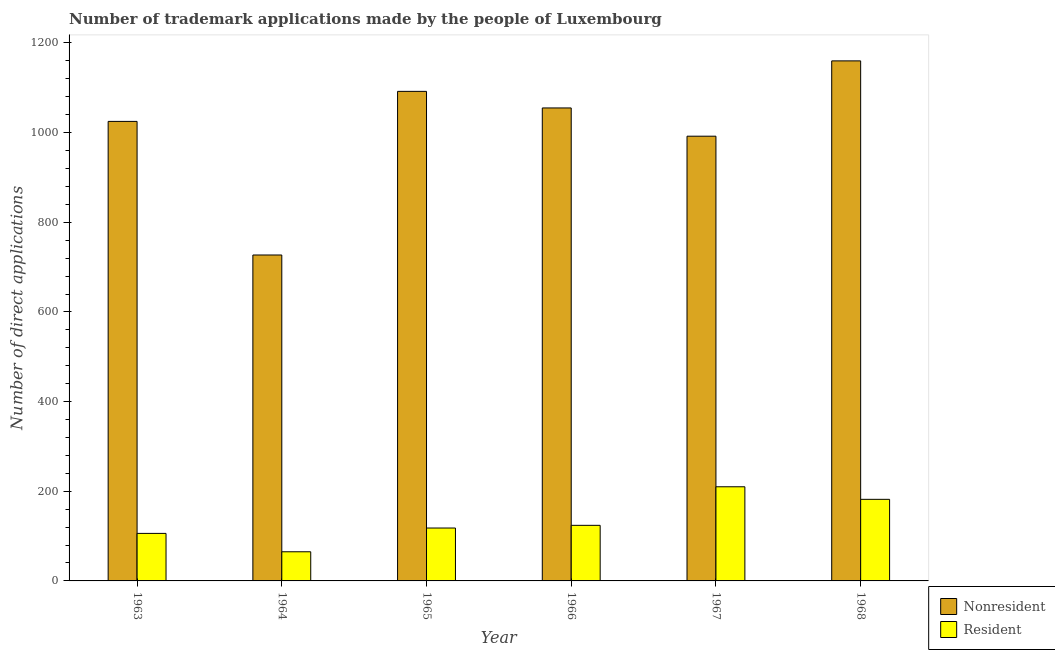How many different coloured bars are there?
Provide a short and direct response. 2. How many groups of bars are there?
Your answer should be compact. 6. What is the label of the 6th group of bars from the left?
Offer a very short reply. 1968. What is the number of trademark applications made by residents in 1965?
Give a very brief answer. 118. Across all years, what is the maximum number of trademark applications made by non residents?
Your answer should be compact. 1160. Across all years, what is the minimum number of trademark applications made by residents?
Your answer should be compact. 65. In which year was the number of trademark applications made by residents maximum?
Ensure brevity in your answer.  1967. In which year was the number of trademark applications made by non residents minimum?
Your answer should be compact. 1964. What is the total number of trademark applications made by non residents in the graph?
Your answer should be very brief. 6051. What is the difference between the number of trademark applications made by non residents in 1966 and that in 1967?
Keep it short and to the point. 63. What is the difference between the number of trademark applications made by non residents in 1967 and the number of trademark applications made by residents in 1966?
Offer a very short reply. -63. What is the average number of trademark applications made by residents per year?
Your answer should be compact. 134.17. In the year 1965, what is the difference between the number of trademark applications made by residents and number of trademark applications made by non residents?
Provide a succinct answer. 0. In how many years, is the number of trademark applications made by non residents greater than 200?
Your response must be concise. 6. What is the ratio of the number of trademark applications made by residents in 1965 to that in 1966?
Provide a short and direct response. 0.95. Is the number of trademark applications made by non residents in 1966 less than that in 1967?
Provide a short and direct response. No. Is the difference between the number of trademark applications made by residents in 1964 and 1965 greater than the difference between the number of trademark applications made by non residents in 1964 and 1965?
Your response must be concise. No. What is the difference between the highest and the lowest number of trademark applications made by residents?
Provide a succinct answer. 145. Is the sum of the number of trademark applications made by non residents in 1963 and 1966 greater than the maximum number of trademark applications made by residents across all years?
Offer a terse response. Yes. What does the 2nd bar from the left in 1963 represents?
Provide a short and direct response. Resident. What does the 1st bar from the right in 1967 represents?
Provide a short and direct response. Resident. Are all the bars in the graph horizontal?
Provide a succinct answer. No. How many years are there in the graph?
Your response must be concise. 6. Are the values on the major ticks of Y-axis written in scientific E-notation?
Provide a succinct answer. No. Does the graph contain any zero values?
Make the answer very short. No. Does the graph contain grids?
Your response must be concise. No. How many legend labels are there?
Your answer should be very brief. 2. What is the title of the graph?
Provide a succinct answer. Number of trademark applications made by the people of Luxembourg. Does "Nonresident" appear as one of the legend labels in the graph?
Offer a very short reply. Yes. What is the label or title of the Y-axis?
Provide a short and direct response. Number of direct applications. What is the Number of direct applications of Nonresident in 1963?
Offer a very short reply. 1025. What is the Number of direct applications in Resident in 1963?
Ensure brevity in your answer.  106. What is the Number of direct applications of Nonresident in 1964?
Keep it short and to the point. 727. What is the Number of direct applications in Resident in 1964?
Provide a short and direct response. 65. What is the Number of direct applications of Nonresident in 1965?
Provide a succinct answer. 1092. What is the Number of direct applications of Resident in 1965?
Provide a succinct answer. 118. What is the Number of direct applications of Nonresident in 1966?
Provide a short and direct response. 1055. What is the Number of direct applications of Resident in 1966?
Provide a succinct answer. 124. What is the Number of direct applications of Nonresident in 1967?
Keep it short and to the point. 992. What is the Number of direct applications of Resident in 1967?
Provide a succinct answer. 210. What is the Number of direct applications of Nonresident in 1968?
Make the answer very short. 1160. What is the Number of direct applications of Resident in 1968?
Your answer should be very brief. 182. Across all years, what is the maximum Number of direct applications of Nonresident?
Make the answer very short. 1160. Across all years, what is the maximum Number of direct applications of Resident?
Make the answer very short. 210. Across all years, what is the minimum Number of direct applications of Nonresident?
Your answer should be very brief. 727. Across all years, what is the minimum Number of direct applications of Resident?
Offer a terse response. 65. What is the total Number of direct applications of Nonresident in the graph?
Your answer should be compact. 6051. What is the total Number of direct applications of Resident in the graph?
Your answer should be very brief. 805. What is the difference between the Number of direct applications in Nonresident in 1963 and that in 1964?
Your answer should be compact. 298. What is the difference between the Number of direct applications of Nonresident in 1963 and that in 1965?
Your answer should be very brief. -67. What is the difference between the Number of direct applications of Resident in 1963 and that in 1965?
Offer a very short reply. -12. What is the difference between the Number of direct applications of Resident in 1963 and that in 1966?
Offer a very short reply. -18. What is the difference between the Number of direct applications in Resident in 1963 and that in 1967?
Provide a succinct answer. -104. What is the difference between the Number of direct applications of Nonresident in 1963 and that in 1968?
Offer a terse response. -135. What is the difference between the Number of direct applications of Resident in 1963 and that in 1968?
Ensure brevity in your answer.  -76. What is the difference between the Number of direct applications in Nonresident in 1964 and that in 1965?
Make the answer very short. -365. What is the difference between the Number of direct applications of Resident in 1964 and that in 1965?
Provide a short and direct response. -53. What is the difference between the Number of direct applications in Nonresident in 1964 and that in 1966?
Your answer should be compact. -328. What is the difference between the Number of direct applications in Resident in 1964 and that in 1966?
Provide a succinct answer. -59. What is the difference between the Number of direct applications of Nonresident in 1964 and that in 1967?
Ensure brevity in your answer.  -265. What is the difference between the Number of direct applications of Resident in 1964 and that in 1967?
Offer a terse response. -145. What is the difference between the Number of direct applications in Nonresident in 1964 and that in 1968?
Make the answer very short. -433. What is the difference between the Number of direct applications in Resident in 1964 and that in 1968?
Give a very brief answer. -117. What is the difference between the Number of direct applications in Resident in 1965 and that in 1967?
Ensure brevity in your answer.  -92. What is the difference between the Number of direct applications of Nonresident in 1965 and that in 1968?
Offer a very short reply. -68. What is the difference between the Number of direct applications in Resident in 1965 and that in 1968?
Your response must be concise. -64. What is the difference between the Number of direct applications of Nonresident in 1966 and that in 1967?
Provide a succinct answer. 63. What is the difference between the Number of direct applications in Resident in 1966 and that in 1967?
Offer a very short reply. -86. What is the difference between the Number of direct applications in Nonresident in 1966 and that in 1968?
Ensure brevity in your answer.  -105. What is the difference between the Number of direct applications in Resident in 1966 and that in 1968?
Offer a very short reply. -58. What is the difference between the Number of direct applications in Nonresident in 1967 and that in 1968?
Give a very brief answer. -168. What is the difference between the Number of direct applications of Nonresident in 1963 and the Number of direct applications of Resident in 1964?
Provide a short and direct response. 960. What is the difference between the Number of direct applications in Nonresident in 1963 and the Number of direct applications in Resident in 1965?
Offer a very short reply. 907. What is the difference between the Number of direct applications in Nonresident in 1963 and the Number of direct applications in Resident in 1966?
Your response must be concise. 901. What is the difference between the Number of direct applications of Nonresident in 1963 and the Number of direct applications of Resident in 1967?
Offer a terse response. 815. What is the difference between the Number of direct applications in Nonresident in 1963 and the Number of direct applications in Resident in 1968?
Provide a succinct answer. 843. What is the difference between the Number of direct applications in Nonresident in 1964 and the Number of direct applications in Resident in 1965?
Your answer should be very brief. 609. What is the difference between the Number of direct applications in Nonresident in 1964 and the Number of direct applications in Resident in 1966?
Your response must be concise. 603. What is the difference between the Number of direct applications in Nonresident in 1964 and the Number of direct applications in Resident in 1967?
Give a very brief answer. 517. What is the difference between the Number of direct applications of Nonresident in 1964 and the Number of direct applications of Resident in 1968?
Ensure brevity in your answer.  545. What is the difference between the Number of direct applications in Nonresident in 1965 and the Number of direct applications in Resident in 1966?
Give a very brief answer. 968. What is the difference between the Number of direct applications in Nonresident in 1965 and the Number of direct applications in Resident in 1967?
Give a very brief answer. 882. What is the difference between the Number of direct applications in Nonresident in 1965 and the Number of direct applications in Resident in 1968?
Your response must be concise. 910. What is the difference between the Number of direct applications of Nonresident in 1966 and the Number of direct applications of Resident in 1967?
Your response must be concise. 845. What is the difference between the Number of direct applications in Nonresident in 1966 and the Number of direct applications in Resident in 1968?
Your answer should be compact. 873. What is the difference between the Number of direct applications in Nonresident in 1967 and the Number of direct applications in Resident in 1968?
Your answer should be compact. 810. What is the average Number of direct applications in Nonresident per year?
Your answer should be very brief. 1008.5. What is the average Number of direct applications in Resident per year?
Your answer should be very brief. 134.17. In the year 1963, what is the difference between the Number of direct applications in Nonresident and Number of direct applications in Resident?
Your response must be concise. 919. In the year 1964, what is the difference between the Number of direct applications in Nonresident and Number of direct applications in Resident?
Offer a terse response. 662. In the year 1965, what is the difference between the Number of direct applications of Nonresident and Number of direct applications of Resident?
Your answer should be compact. 974. In the year 1966, what is the difference between the Number of direct applications of Nonresident and Number of direct applications of Resident?
Give a very brief answer. 931. In the year 1967, what is the difference between the Number of direct applications in Nonresident and Number of direct applications in Resident?
Give a very brief answer. 782. In the year 1968, what is the difference between the Number of direct applications of Nonresident and Number of direct applications of Resident?
Offer a terse response. 978. What is the ratio of the Number of direct applications in Nonresident in 1963 to that in 1964?
Ensure brevity in your answer.  1.41. What is the ratio of the Number of direct applications in Resident in 1963 to that in 1964?
Ensure brevity in your answer.  1.63. What is the ratio of the Number of direct applications of Nonresident in 1963 to that in 1965?
Your answer should be very brief. 0.94. What is the ratio of the Number of direct applications of Resident in 1963 to that in 1965?
Provide a succinct answer. 0.9. What is the ratio of the Number of direct applications of Nonresident in 1963 to that in 1966?
Your response must be concise. 0.97. What is the ratio of the Number of direct applications in Resident in 1963 to that in 1966?
Provide a succinct answer. 0.85. What is the ratio of the Number of direct applications in Nonresident in 1963 to that in 1967?
Provide a succinct answer. 1.03. What is the ratio of the Number of direct applications in Resident in 1963 to that in 1967?
Offer a very short reply. 0.5. What is the ratio of the Number of direct applications in Nonresident in 1963 to that in 1968?
Your answer should be compact. 0.88. What is the ratio of the Number of direct applications of Resident in 1963 to that in 1968?
Keep it short and to the point. 0.58. What is the ratio of the Number of direct applications in Nonresident in 1964 to that in 1965?
Your response must be concise. 0.67. What is the ratio of the Number of direct applications in Resident in 1964 to that in 1965?
Ensure brevity in your answer.  0.55. What is the ratio of the Number of direct applications of Nonresident in 1964 to that in 1966?
Your answer should be very brief. 0.69. What is the ratio of the Number of direct applications of Resident in 1964 to that in 1966?
Your answer should be compact. 0.52. What is the ratio of the Number of direct applications in Nonresident in 1964 to that in 1967?
Your answer should be very brief. 0.73. What is the ratio of the Number of direct applications in Resident in 1964 to that in 1967?
Offer a terse response. 0.31. What is the ratio of the Number of direct applications of Nonresident in 1964 to that in 1968?
Give a very brief answer. 0.63. What is the ratio of the Number of direct applications in Resident in 1964 to that in 1968?
Provide a short and direct response. 0.36. What is the ratio of the Number of direct applications of Nonresident in 1965 to that in 1966?
Give a very brief answer. 1.04. What is the ratio of the Number of direct applications in Resident in 1965 to that in 1966?
Your answer should be very brief. 0.95. What is the ratio of the Number of direct applications in Nonresident in 1965 to that in 1967?
Make the answer very short. 1.1. What is the ratio of the Number of direct applications in Resident in 1965 to that in 1967?
Provide a succinct answer. 0.56. What is the ratio of the Number of direct applications in Nonresident in 1965 to that in 1968?
Offer a terse response. 0.94. What is the ratio of the Number of direct applications in Resident in 1965 to that in 1968?
Ensure brevity in your answer.  0.65. What is the ratio of the Number of direct applications in Nonresident in 1966 to that in 1967?
Your answer should be compact. 1.06. What is the ratio of the Number of direct applications of Resident in 1966 to that in 1967?
Provide a short and direct response. 0.59. What is the ratio of the Number of direct applications in Nonresident in 1966 to that in 1968?
Keep it short and to the point. 0.91. What is the ratio of the Number of direct applications in Resident in 1966 to that in 1968?
Your answer should be compact. 0.68. What is the ratio of the Number of direct applications in Nonresident in 1967 to that in 1968?
Give a very brief answer. 0.86. What is the ratio of the Number of direct applications of Resident in 1967 to that in 1968?
Offer a terse response. 1.15. What is the difference between the highest and the second highest Number of direct applications in Resident?
Keep it short and to the point. 28. What is the difference between the highest and the lowest Number of direct applications in Nonresident?
Your response must be concise. 433. What is the difference between the highest and the lowest Number of direct applications in Resident?
Ensure brevity in your answer.  145. 